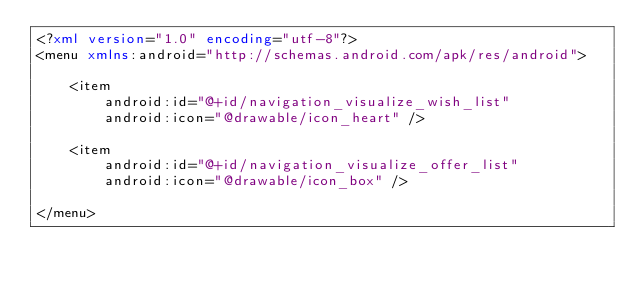<code> <loc_0><loc_0><loc_500><loc_500><_XML_><?xml version="1.0" encoding="utf-8"?>
<menu xmlns:android="http://schemas.android.com/apk/res/android">

    <item
        android:id="@+id/navigation_visualize_wish_list"
        android:icon="@drawable/icon_heart" />

    <item
        android:id="@+id/navigation_visualize_offer_list"
        android:icon="@drawable/icon_box" />

</menu></code> 